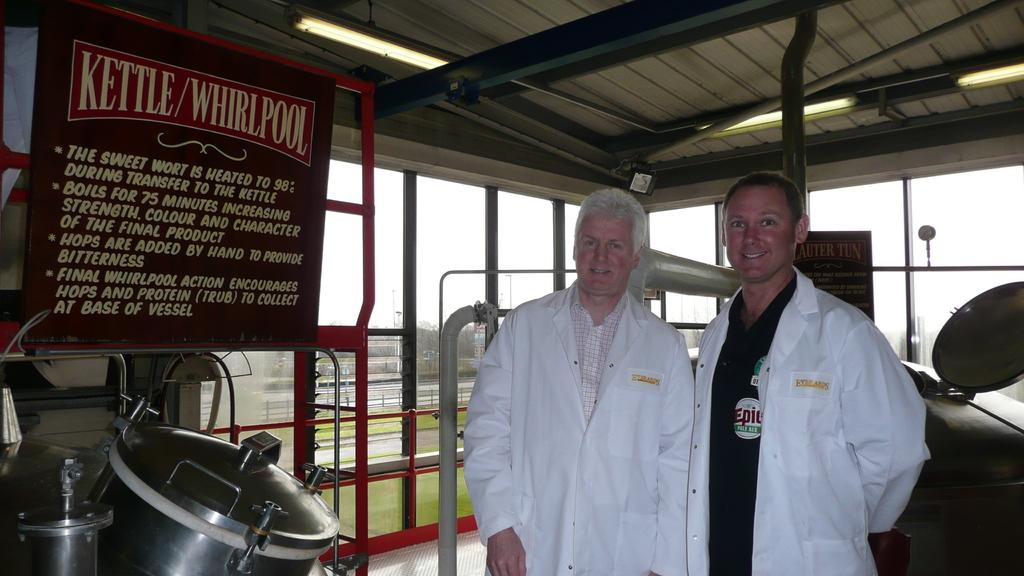<image>
Present a compact description of the photo's key features. two white robbed people stand by a sign for Kettle Whirlpool 